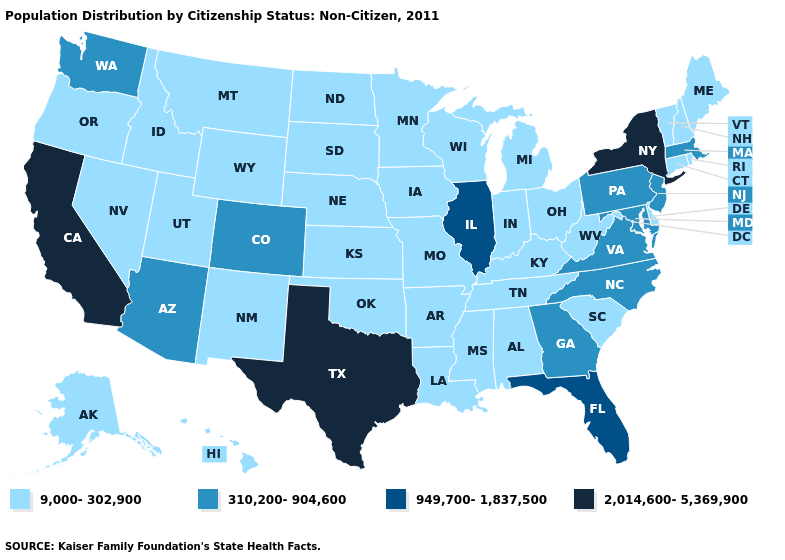How many symbols are there in the legend?
Write a very short answer. 4. Which states have the lowest value in the South?
Be succinct. Alabama, Arkansas, Delaware, Kentucky, Louisiana, Mississippi, Oklahoma, South Carolina, Tennessee, West Virginia. Does the map have missing data?
Be succinct. No. What is the value of Minnesota?
Write a very short answer. 9,000-302,900. How many symbols are there in the legend?
Be succinct. 4. Name the states that have a value in the range 310,200-904,600?
Give a very brief answer. Arizona, Colorado, Georgia, Maryland, Massachusetts, New Jersey, North Carolina, Pennsylvania, Virginia, Washington. What is the value of Wyoming?
Write a very short answer. 9,000-302,900. What is the highest value in states that border Louisiana?
Answer briefly. 2,014,600-5,369,900. What is the lowest value in the USA?
Keep it brief. 9,000-302,900. Among the states that border Indiana , does Illinois have the lowest value?
Give a very brief answer. No. Does the map have missing data?
Concise answer only. No. What is the value of New Jersey?
Short answer required. 310,200-904,600. Does Louisiana have a lower value than Minnesota?
Answer briefly. No. Name the states that have a value in the range 310,200-904,600?
Answer briefly. Arizona, Colorado, Georgia, Maryland, Massachusetts, New Jersey, North Carolina, Pennsylvania, Virginia, Washington. 